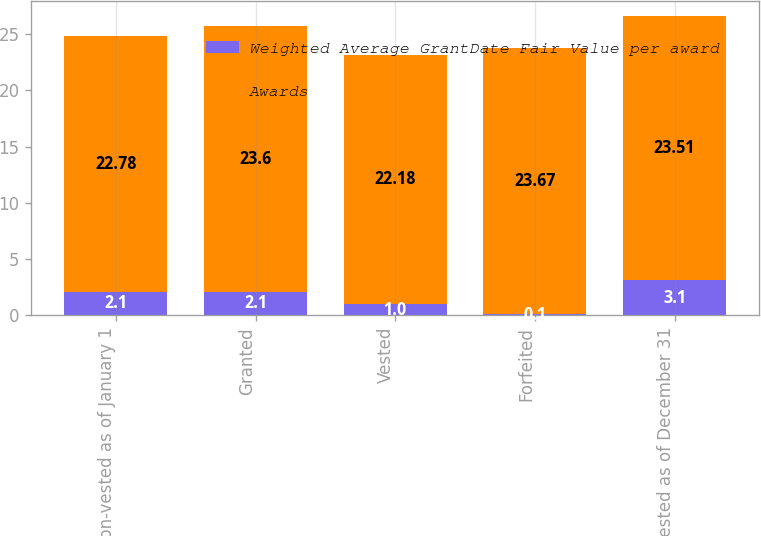<chart> <loc_0><loc_0><loc_500><loc_500><stacked_bar_chart><ecel><fcel>Non-vested as of January 1<fcel>Granted<fcel>Vested<fcel>Forfeited<fcel>Non-vested as of December 31<nl><fcel>Weighted Average GrantDate Fair Value per award<fcel>2.1<fcel>2.1<fcel>1<fcel>0.1<fcel>3.1<nl><fcel>Awards<fcel>22.78<fcel>23.6<fcel>22.18<fcel>23.67<fcel>23.51<nl></chart> 